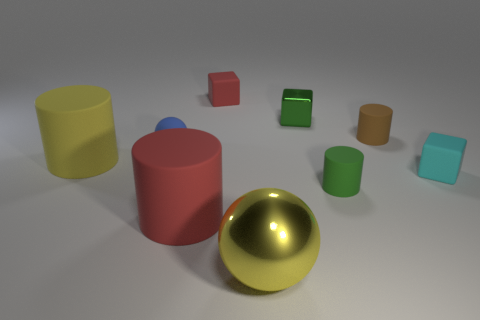What material is the tiny cylinder that is the same color as the metal cube?
Provide a succinct answer. Rubber. How many tiny red cubes are the same material as the tiny sphere?
Your answer should be very brief. 1. What number of spheres are behind the sphere behind the large shiny thing?
Offer a very short reply. 0. What number of cubes are there?
Offer a terse response. 3. Are the large yellow ball and the cube behind the metallic block made of the same material?
Your answer should be very brief. No. There is a matte cube that is on the left side of the yellow ball; does it have the same color as the large metallic object?
Your answer should be very brief. No. There is a cube that is in front of the red block and behind the blue thing; what is its material?
Keep it short and to the point. Metal. What is the size of the green matte thing?
Provide a succinct answer. Small. There is a large shiny object; does it have the same color as the large rubber thing that is behind the small cyan matte block?
Your answer should be very brief. Yes. What number of other objects are there of the same color as the metallic sphere?
Offer a very short reply. 1. 